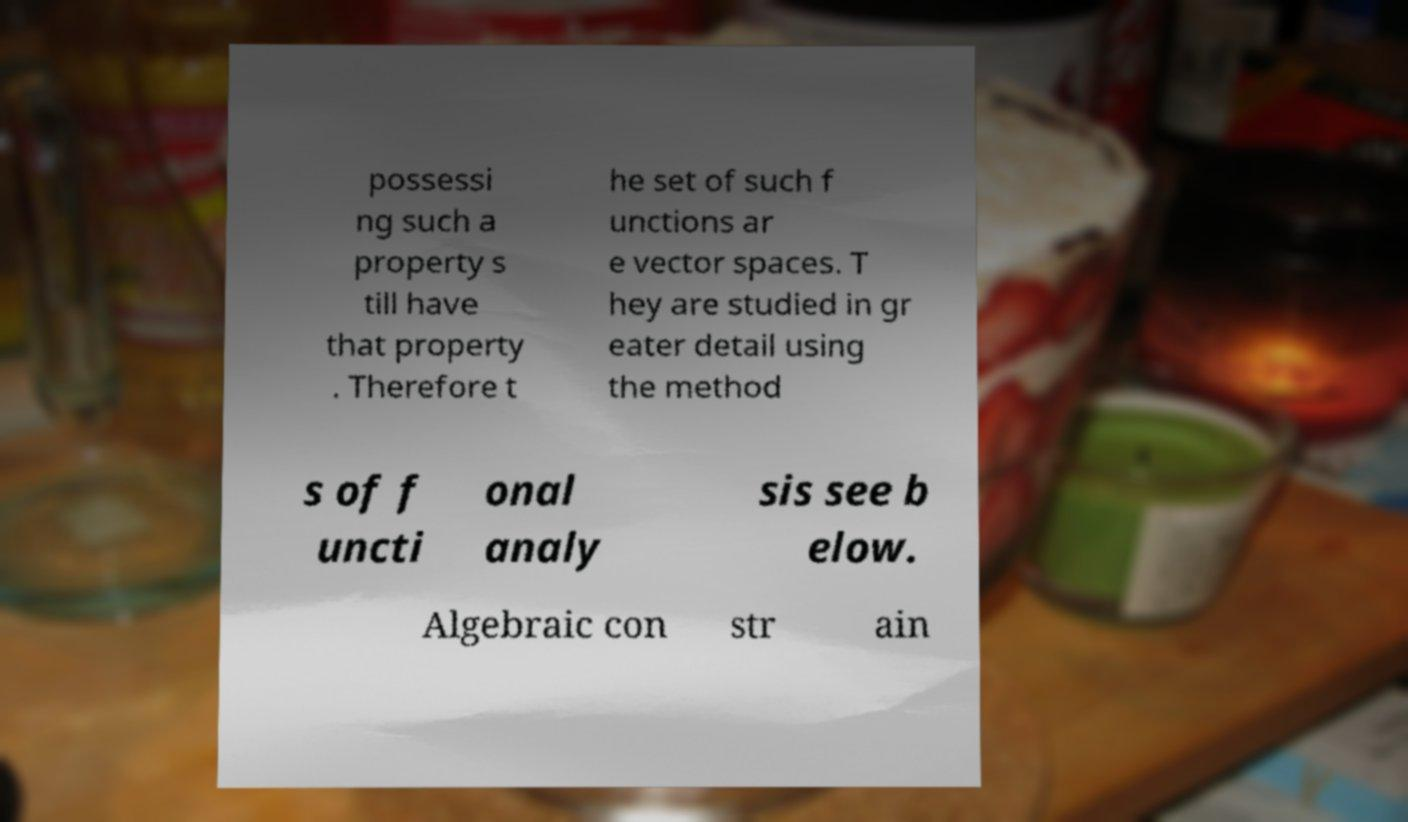I need the written content from this picture converted into text. Can you do that? possessi ng such a property s till have that property . Therefore t he set of such f unctions ar e vector spaces. T hey are studied in gr eater detail using the method s of f uncti onal analy sis see b elow. Algebraic con str ain 